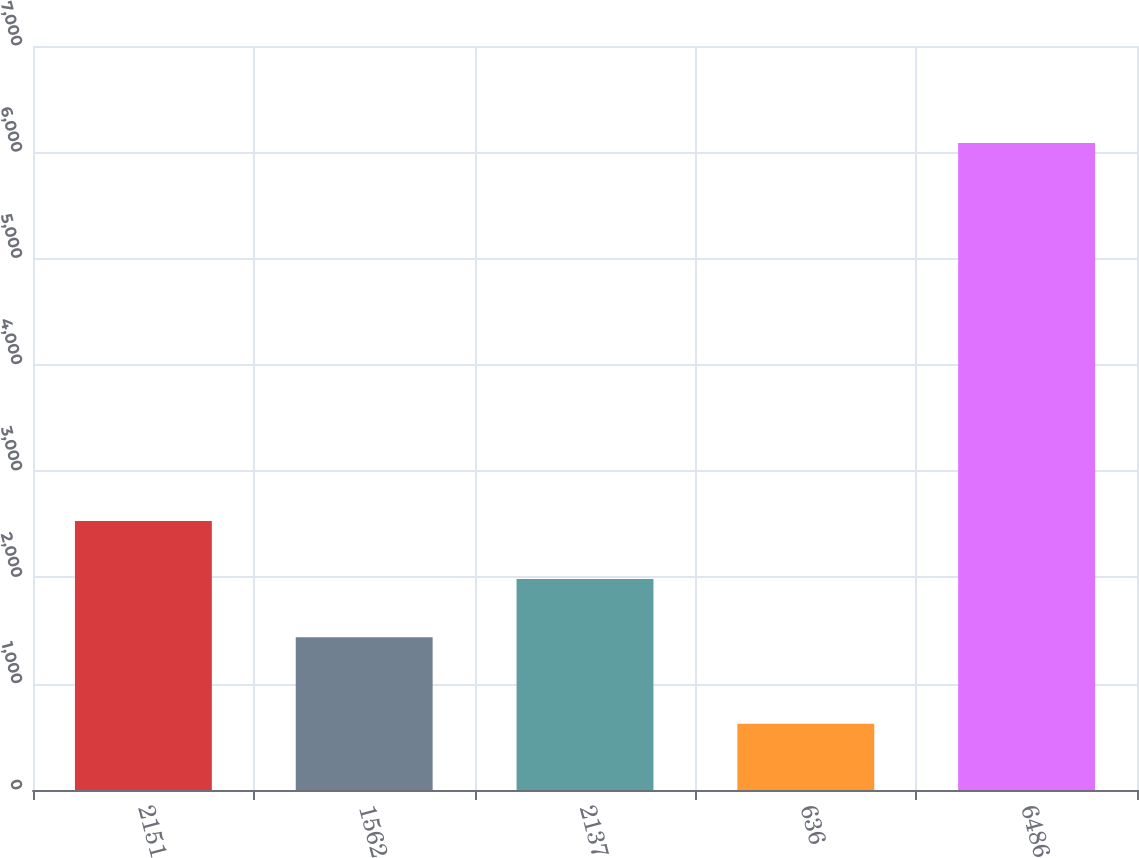Convert chart. <chart><loc_0><loc_0><loc_500><loc_500><bar_chart><fcel>2151<fcel>1562<fcel>2137<fcel>636<fcel>6486<nl><fcel>2530.6<fcel>1438<fcel>1984.3<fcel>624<fcel>6087<nl></chart> 